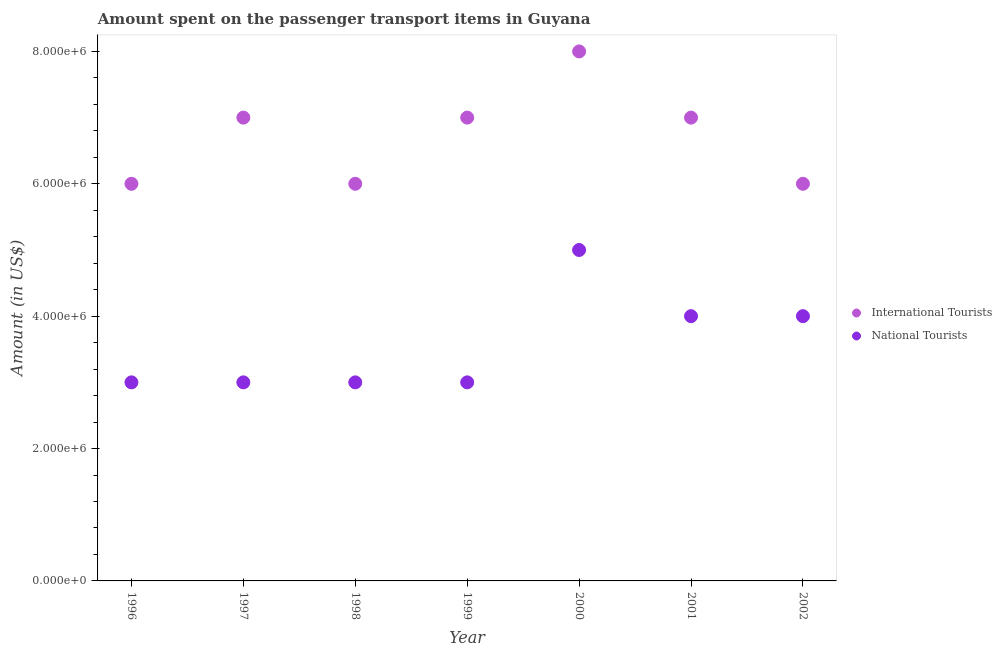How many different coloured dotlines are there?
Give a very brief answer. 2. What is the amount spent on transport items of international tourists in 2002?
Offer a very short reply. 6.00e+06. Across all years, what is the maximum amount spent on transport items of international tourists?
Make the answer very short. 8.00e+06. Across all years, what is the minimum amount spent on transport items of international tourists?
Make the answer very short. 6.00e+06. In which year was the amount spent on transport items of international tourists maximum?
Keep it short and to the point. 2000. In which year was the amount spent on transport items of national tourists minimum?
Make the answer very short. 1996. What is the total amount spent on transport items of international tourists in the graph?
Ensure brevity in your answer.  4.70e+07. What is the difference between the amount spent on transport items of international tourists in 1997 and that in 1999?
Keep it short and to the point. 0. What is the difference between the amount spent on transport items of national tourists in 1999 and the amount spent on transport items of international tourists in 1996?
Make the answer very short. -3.00e+06. What is the average amount spent on transport items of national tourists per year?
Keep it short and to the point. 3.57e+06. In the year 1996, what is the difference between the amount spent on transport items of international tourists and amount spent on transport items of national tourists?
Make the answer very short. 3.00e+06. In how many years, is the amount spent on transport items of national tourists greater than 5200000 US$?
Provide a succinct answer. 0. What is the ratio of the amount spent on transport items of international tourists in 1997 to that in 1998?
Provide a short and direct response. 1.17. Is the amount spent on transport items of international tourists in 1998 less than that in 1999?
Provide a succinct answer. Yes. Is the difference between the amount spent on transport items of national tourists in 1999 and 2001 greater than the difference between the amount spent on transport items of international tourists in 1999 and 2001?
Offer a very short reply. No. What is the difference between the highest and the lowest amount spent on transport items of national tourists?
Keep it short and to the point. 2.00e+06. In how many years, is the amount spent on transport items of international tourists greater than the average amount spent on transport items of international tourists taken over all years?
Provide a succinct answer. 4. Is the amount spent on transport items of international tourists strictly less than the amount spent on transport items of national tourists over the years?
Ensure brevity in your answer.  No. How many dotlines are there?
Keep it short and to the point. 2. Where does the legend appear in the graph?
Offer a very short reply. Center right. What is the title of the graph?
Offer a very short reply. Amount spent on the passenger transport items in Guyana. What is the Amount (in US$) of International Tourists in 1996?
Your answer should be very brief. 6.00e+06. What is the Amount (in US$) of International Tourists in 1998?
Your response must be concise. 6.00e+06. What is the Amount (in US$) of International Tourists in 2002?
Your answer should be compact. 6.00e+06. Across all years, what is the minimum Amount (in US$) in International Tourists?
Your answer should be compact. 6.00e+06. What is the total Amount (in US$) in International Tourists in the graph?
Your response must be concise. 4.70e+07. What is the total Amount (in US$) of National Tourists in the graph?
Offer a terse response. 2.50e+07. What is the difference between the Amount (in US$) of International Tourists in 1996 and that in 1997?
Offer a very short reply. -1.00e+06. What is the difference between the Amount (in US$) of National Tourists in 1996 and that in 1998?
Offer a terse response. 0. What is the difference between the Amount (in US$) of International Tourists in 1996 and that in 2000?
Your answer should be very brief. -2.00e+06. What is the difference between the Amount (in US$) in National Tourists in 1996 and that in 2000?
Make the answer very short. -2.00e+06. What is the difference between the Amount (in US$) of National Tourists in 1996 and that in 2001?
Your answer should be compact. -1.00e+06. What is the difference between the Amount (in US$) of National Tourists in 1996 and that in 2002?
Your answer should be compact. -1.00e+06. What is the difference between the Amount (in US$) in National Tourists in 1997 and that in 1998?
Your response must be concise. 0. What is the difference between the Amount (in US$) in National Tourists in 1997 and that in 1999?
Provide a succinct answer. 0. What is the difference between the Amount (in US$) of International Tourists in 1997 and that in 2001?
Your answer should be compact. 0. What is the difference between the Amount (in US$) in National Tourists in 1997 and that in 2001?
Keep it short and to the point. -1.00e+06. What is the difference between the Amount (in US$) in National Tourists in 1997 and that in 2002?
Make the answer very short. -1.00e+06. What is the difference between the Amount (in US$) in International Tourists in 1998 and that in 2000?
Ensure brevity in your answer.  -2.00e+06. What is the difference between the Amount (in US$) of National Tourists in 1998 and that in 2000?
Offer a very short reply. -2.00e+06. What is the difference between the Amount (in US$) in National Tourists in 1998 and that in 2001?
Your answer should be compact. -1.00e+06. What is the difference between the Amount (in US$) in International Tourists in 1998 and that in 2002?
Provide a succinct answer. 0. What is the difference between the Amount (in US$) in International Tourists in 1999 and that in 2000?
Give a very brief answer. -1.00e+06. What is the difference between the Amount (in US$) in National Tourists in 1999 and that in 2000?
Offer a very short reply. -2.00e+06. What is the difference between the Amount (in US$) in National Tourists in 1999 and that in 2001?
Your answer should be very brief. -1.00e+06. What is the difference between the Amount (in US$) of International Tourists in 1999 and that in 2002?
Your answer should be compact. 1.00e+06. What is the difference between the Amount (in US$) of National Tourists in 1999 and that in 2002?
Your response must be concise. -1.00e+06. What is the difference between the Amount (in US$) in International Tourists in 2000 and that in 2002?
Your response must be concise. 2.00e+06. What is the difference between the Amount (in US$) in International Tourists in 1996 and the Amount (in US$) in National Tourists in 1997?
Provide a short and direct response. 3.00e+06. What is the difference between the Amount (in US$) of International Tourists in 1996 and the Amount (in US$) of National Tourists in 2001?
Offer a terse response. 2.00e+06. What is the difference between the Amount (in US$) in International Tourists in 1998 and the Amount (in US$) in National Tourists in 2001?
Keep it short and to the point. 2.00e+06. What is the difference between the Amount (in US$) of International Tourists in 1998 and the Amount (in US$) of National Tourists in 2002?
Ensure brevity in your answer.  2.00e+06. What is the difference between the Amount (in US$) in International Tourists in 1999 and the Amount (in US$) in National Tourists in 2000?
Your answer should be compact. 2.00e+06. What is the difference between the Amount (in US$) of International Tourists in 1999 and the Amount (in US$) of National Tourists in 2001?
Offer a very short reply. 3.00e+06. What is the difference between the Amount (in US$) of International Tourists in 1999 and the Amount (in US$) of National Tourists in 2002?
Your answer should be compact. 3.00e+06. What is the difference between the Amount (in US$) of International Tourists in 2000 and the Amount (in US$) of National Tourists in 2001?
Provide a short and direct response. 4.00e+06. What is the difference between the Amount (in US$) of International Tourists in 2000 and the Amount (in US$) of National Tourists in 2002?
Ensure brevity in your answer.  4.00e+06. What is the difference between the Amount (in US$) of International Tourists in 2001 and the Amount (in US$) of National Tourists in 2002?
Your answer should be very brief. 3.00e+06. What is the average Amount (in US$) in International Tourists per year?
Provide a succinct answer. 6.71e+06. What is the average Amount (in US$) in National Tourists per year?
Offer a terse response. 3.57e+06. In the year 1996, what is the difference between the Amount (in US$) in International Tourists and Amount (in US$) in National Tourists?
Your answer should be compact. 3.00e+06. In the year 1999, what is the difference between the Amount (in US$) of International Tourists and Amount (in US$) of National Tourists?
Offer a very short reply. 4.00e+06. In the year 2002, what is the difference between the Amount (in US$) in International Tourists and Amount (in US$) in National Tourists?
Provide a succinct answer. 2.00e+06. What is the ratio of the Amount (in US$) in International Tourists in 1996 to that in 1997?
Ensure brevity in your answer.  0.86. What is the ratio of the Amount (in US$) in International Tourists in 1996 to that in 1998?
Keep it short and to the point. 1. What is the ratio of the Amount (in US$) of National Tourists in 1996 to that in 1998?
Provide a succinct answer. 1. What is the ratio of the Amount (in US$) in National Tourists in 1996 to that in 1999?
Provide a short and direct response. 1. What is the ratio of the Amount (in US$) in International Tourists in 1996 to that in 2000?
Ensure brevity in your answer.  0.75. What is the ratio of the Amount (in US$) of International Tourists in 1996 to that in 2001?
Provide a short and direct response. 0.86. What is the ratio of the Amount (in US$) of National Tourists in 1996 to that in 2001?
Offer a terse response. 0.75. What is the ratio of the Amount (in US$) of International Tourists in 1996 to that in 2002?
Provide a succinct answer. 1. What is the ratio of the Amount (in US$) of International Tourists in 1997 to that in 1998?
Offer a very short reply. 1.17. What is the ratio of the Amount (in US$) of National Tourists in 1997 to that in 1998?
Your answer should be very brief. 1. What is the ratio of the Amount (in US$) of International Tourists in 1997 to that in 1999?
Make the answer very short. 1. What is the ratio of the Amount (in US$) in National Tourists in 1997 to that in 2001?
Your answer should be very brief. 0.75. What is the ratio of the Amount (in US$) of National Tourists in 1997 to that in 2002?
Your response must be concise. 0.75. What is the ratio of the Amount (in US$) in National Tourists in 1998 to that in 1999?
Your answer should be compact. 1. What is the ratio of the Amount (in US$) in National Tourists in 1998 to that in 2001?
Your answer should be compact. 0.75. What is the ratio of the Amount (in US$) of International Tourists in 1998 to that in 2002?
Provide a short and direct response. 1. What is the ratio of the Amount (in US$) in National Tourists in 1999 to that in 2001?
Ensure brevity in your answer.  0.75. What is the ratio of the Amount (in US$) of National Tourists in 1999 to that in 2002?
Keep it short and to the point. 0.75. What is the ratio of the Amount (in US$) of National Tourists in 2000 to that in 2001?
Give a very brief answer. 1.25. What is the ratio of the Amount (in US$) of International Tourists in 2001 to that in 2002?
Your answer should be compact. 1.17. What is the difference between the highest and the second highest Amount (in US$) of International Tourists?
Keep it short and to the point. 1.00e+06. What is the difference between the highest and the second highest Amount (in US$) in National Tourists?
Provide a short and direct response. 1.00e+06. What is the difference between the highest and the lowest Amount (in US$) in International Tourists?
Your answer should be very brief. 2.00e+06. What is the difference between the highest and the lowest Amount (in US$) of National Tourists?
Keep it short and to the point. 2.00e+06. 